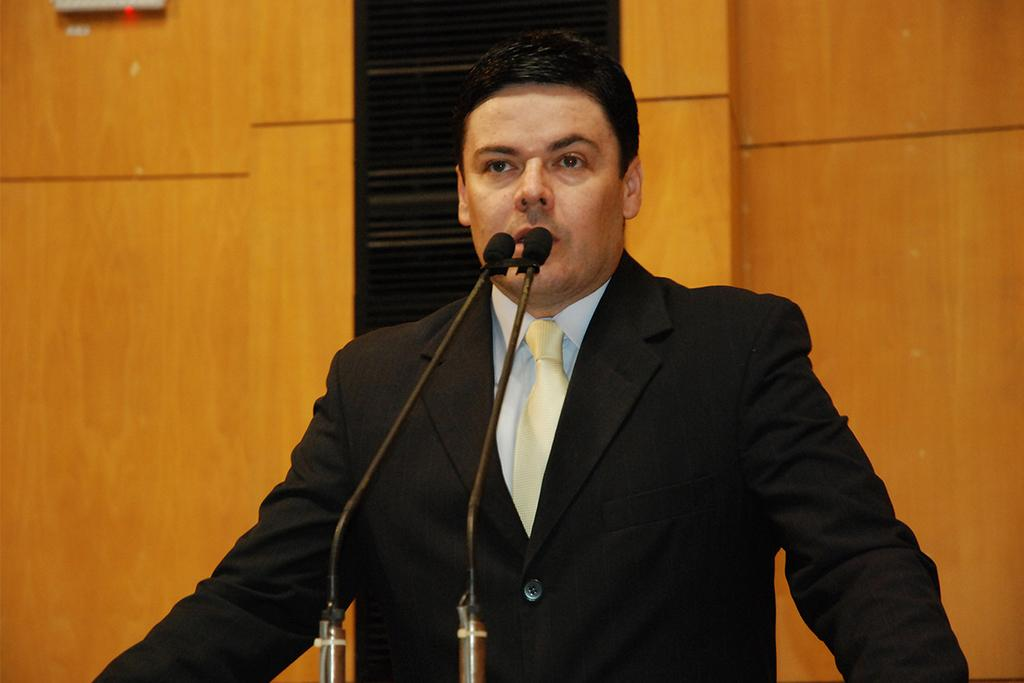Who is the main subject in the image? There is a person in the center of the image. What is the person doing in the image? The person is talking. What objects are in front of the person? There are microphones in front of the person. What can be seen in the background of the image? There is a wooden wall and objects visible in the background of the image. What type of dinner is being served in the image? There is no dinner present in the image; it features a person talking with microphones in front of them. Is there a spy visible in the image? There is no indication of a spy in the image; it shows a person talking with microphones in front of them. 